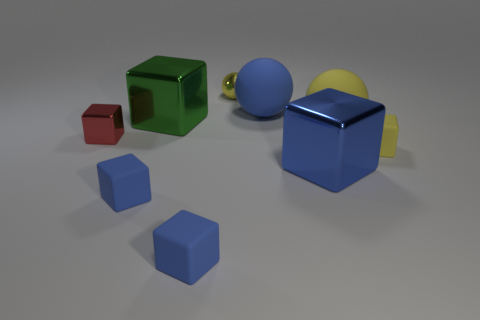What color is the tiny metal block?
Provide a short and direct response. Red. There is another sphere that is the same material as the big yellow sphere; what size is it?
Your answer should be compact. Large. There is a rubber sphere that is on the left side of the shiny thing that is to the right of the yellow shiny ball; what number of green cubes are in front of it?
Make the answer very short. 1. Is the color of the tiny metallic sphere the same as the ball in front of the large blue matte ball?
Your response must be concise. Yes. What is the shape of the big rubber object that is the same color as the small shiny ball?
Offer a very short reply. Sphere. What material is the blue thing that is behind the small yellow thing right of the big thing that is in front of the yellow matte cube made of?
Your answer should be very brief. Rubber. There is a large matte thing that is to the left of the big yellow rubber object; is its shape the same as the yellow shiny thing?
Offer a very short reply. Yes. There is a object that is right of the big yellow matte object; what is its material?
Offer a terse response. Rubber. How many matte objects are green objects or red objects?
Provide a short and direct response. 0. Is there a gray metal sphere that has the same size as the yellow metallic object?
Provide a succinct answer. No. 